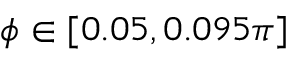Convert formula to latex. <formula><loc_0><loc_0><loc_500><loc_500>\phi \in [ 0 . 0 5 , 0 . 0 9 5 \pi ]</formula> 